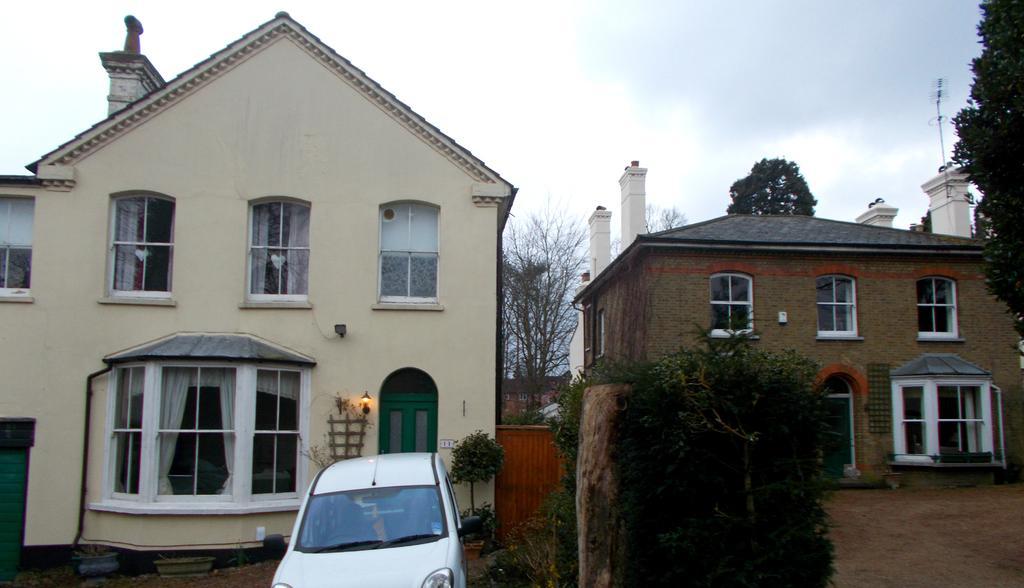In one or two sentences, can you explain what this image depicts? On the left side there is a building with windows. Near to the building there is a car. Also there are trees. On the right side there is a building with windows. In the background there are trees. Also there is sky. 